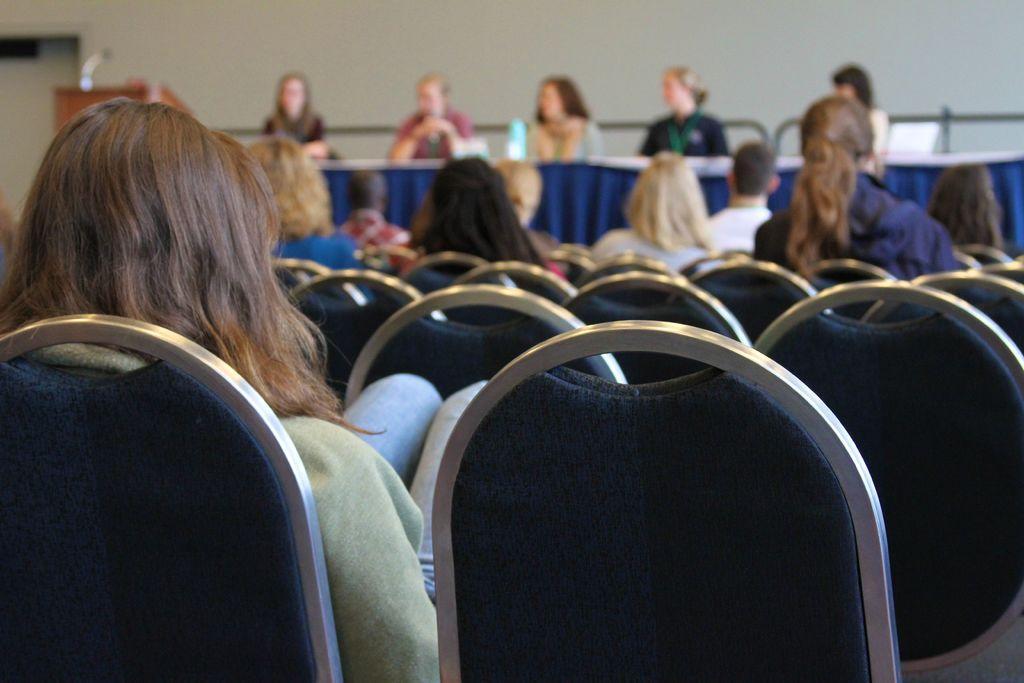Can you describe this image briefly? In this image I can see number of people are sitting on chairs. I can also see few empty chairs in the front and on the top left side of this image I can see a podium. I can also see this image is little bit blurry in the background. 